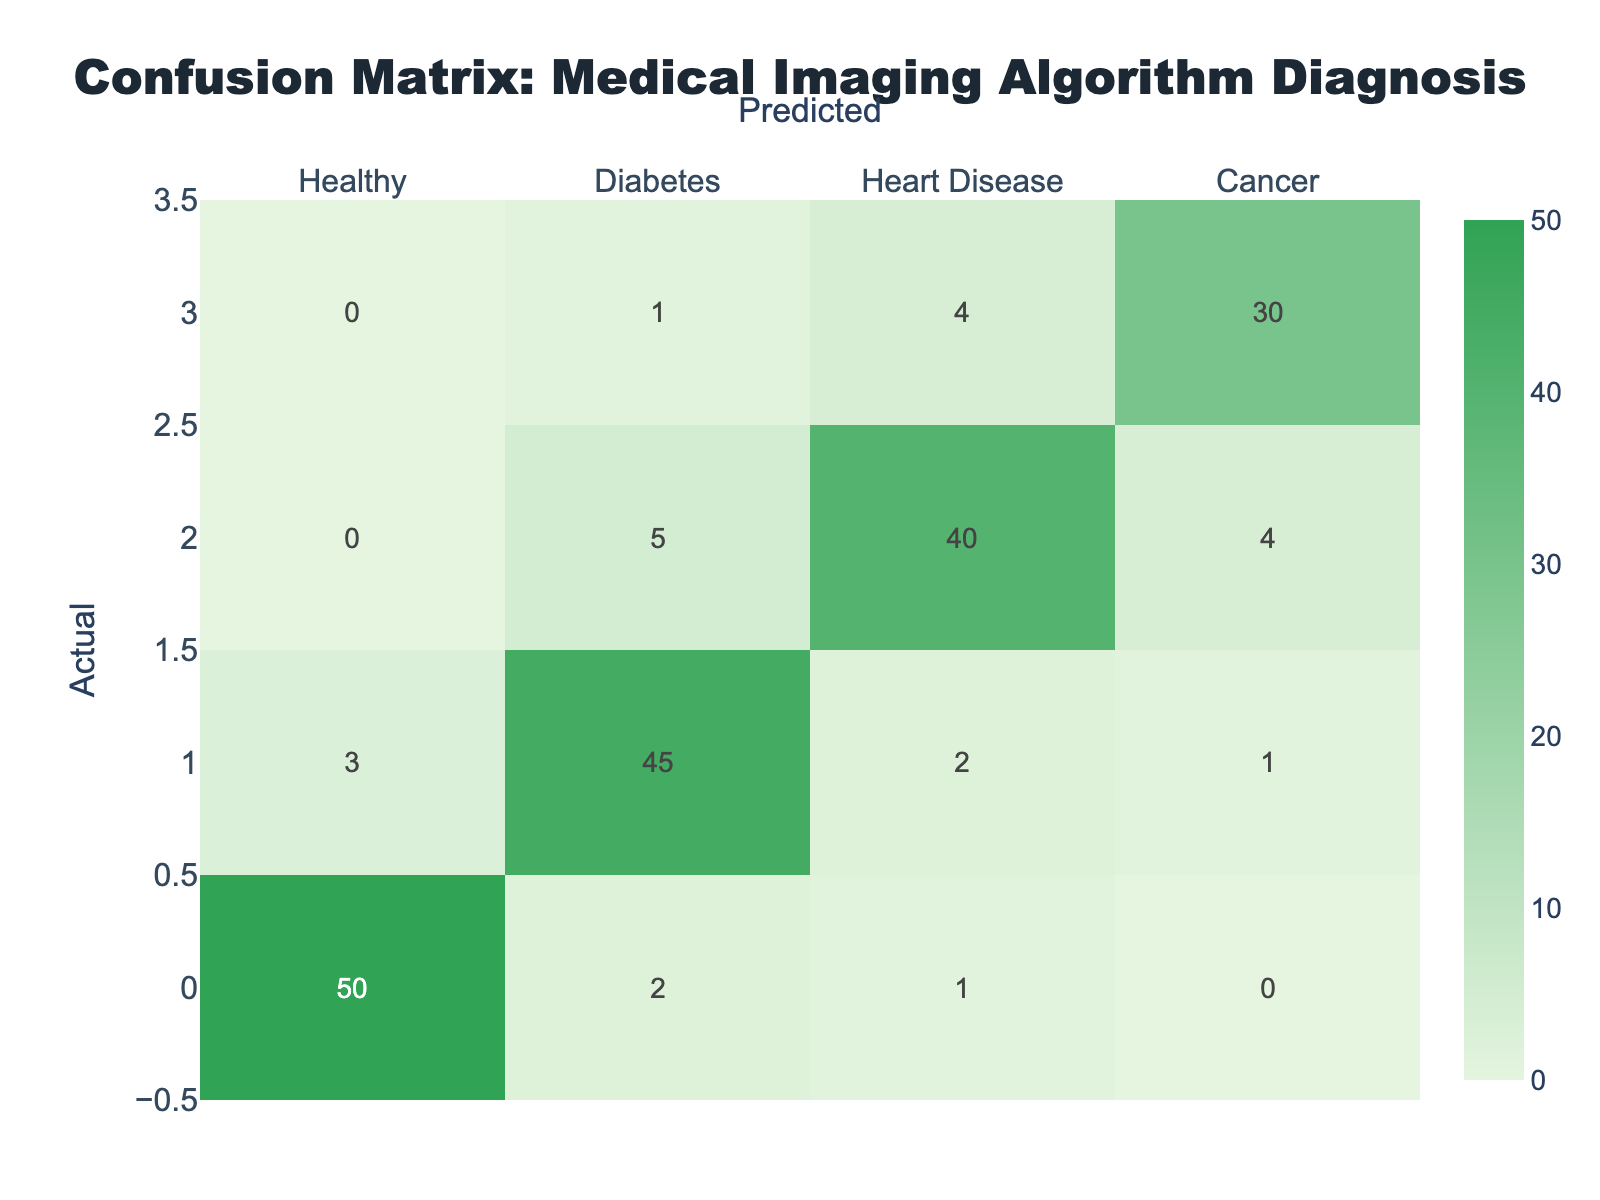What is the predicted count for Healthy individuals? To find the predicted count for Healthy individuals, we look at the column named "Healthy" in the predicted category. The value for Healthy under this column is 50.
Answer: 50 What is the total number of actual cases diagnosed as Diabetes? To determine the total number of actual cases diagnosed as Diabetes, we sum the values in the "Diabetes" row, which are 3 (Healthy), 45 (Diabetes), 2 (Heart Disease), and 1 (Cancer). The total is 3 + 45 + 2 + 1 = 51.
Answer: 51 Is the diagnosis of Heart Disease more accurate than Cancer based on the confusion matrix? We compare the actual counts of correctly diagnosed Heart Disease (40) and Cancer (30) cases. Since 40 is greater than 30, Heart Disease is diagnosed more accurately than Cancer.
Answer: Yes What is the total number of False Positives for Diabetes? False Positives for Diabetes are found in the "Healthy" and "Heart Disease" rows under the Diabetes column. We have 3 (Healthy) + 5 (Heart Disease) = 8. Thus, the total is 8.
Answer: 8 What percentage of actual Cancer cases were correctly diagnosed? To find the percentage of correctly diagnosed Cancer cases, we take the correct diagnoses (30) from the total actual Cancer cases, which include 1 (Healthy), 0 (Diabetes), 4 (Heart Disease), and 30 (Cancer). The total is 1 + 0 + 4 + 30 = 35. The percentage is (30/35) * 100, which results in approximately 85.71%.
Answer: 85.71% Which disease has the highest misclassification as Diabetes? To find the disease with the highest misclassification as Diabetes, we look at the values in the Diabetes column but outside the Diabetes row. We see 3 (Healthy), 2 (Heart Disease), and 1 (Cancer). The highest value is 3 from the Healthy category.
Answer: Healthy How many total misclassifications occurred for all diseases? Total misclassifications can be calculated by summing up all the values that are not on the diagonal of the confusion matrix. This includes (2 + 1 + 3 + 2 + 1 + 5 + 4 + 1) = 19.
Answer: 19 Is the performance of the model better with Healthy diagnoses compared to Cancer? We compare the number of correctly predicted Healthy cases (50) to correctly predicted Cancer cases (30). Since 50 is greater than 30, the model performs better with Healthy diagnoses.
Answer: Yes What is the ratio of correctly predicted Diabetes cases to total Diabetes cases? The number of correctly predicted Diabetes cases is 45, and the total actual Diabetes cases is 51. The ratio is therefore 45:51, which simplifies to approximately 15:17 after dividing both by 3.
Answer: 15:17 